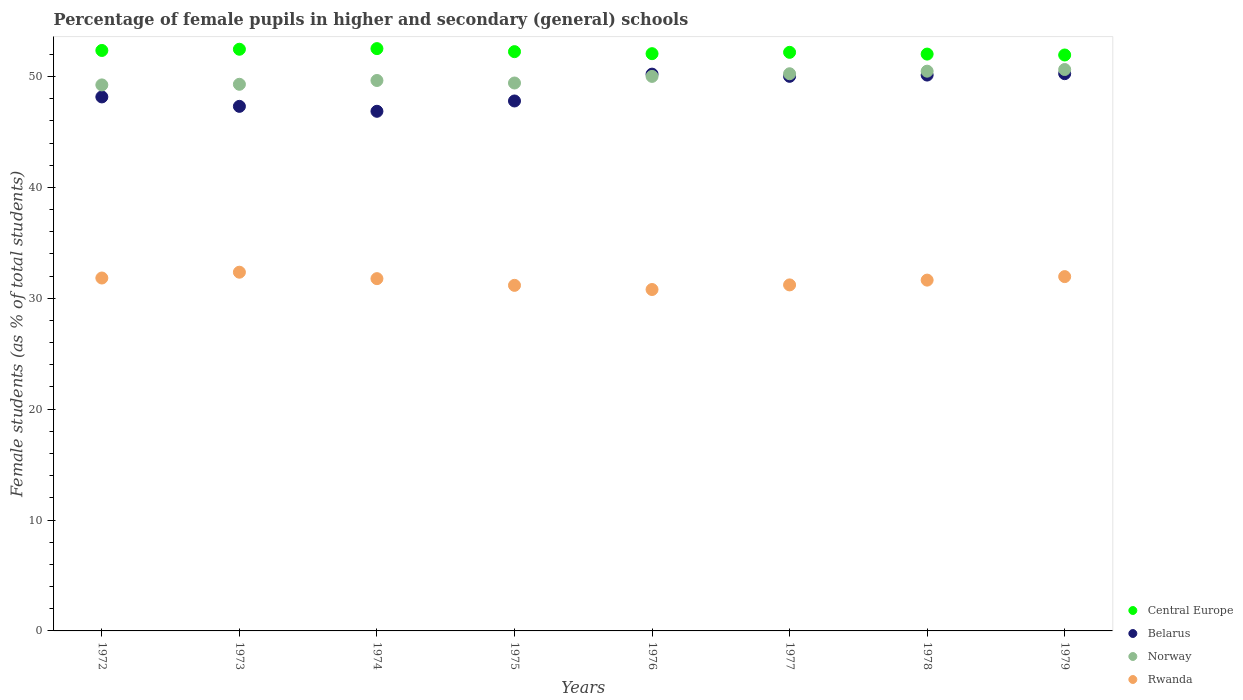What is the percentage of female pupils in higher and secondary schools in Central Europe in 1973?
Your answer should be compact. 52.46. Across all years, what is the maximum percentage of female pupils in higher and secondary schools in Central Europe?
Your answer should be very brief. 52.52. Across all years, what is the minimum percentage of female pupils in higher and secondary schools in Norway?
Provide a short and direct response. 49.24. In which year was the percentage of female pupils in higher and secondary schools in Belarus maximum?
Provide a succinct answer. 1979. In which year was the percentage of female pupils in higher and secondary schools in Rwanda minimum?
Your answer should be very brief. 1976. What is the total percentage of female pupils in higher and secondary schools in Central Europe in the graph?
Your answer should be very brief. 417.77. What is the difference between the percentage of female pupils in higher and secondary schools in Belarus in 1973 and that in 1978?
Ensure brevity in your answer.  -2.82. What is the difference between the percentage of female pupils in higher and secondary schools in Norway in 1977 and the percentage of female pupils in higher and secondary schools in Rwanda in 1974?
Give a very brief answer. 18.48. What is the average percentage of female pupils in higher and secondary schools in Belarus per year?
Give a very brief answer. 48.84. In the year 1974, what is the difference between the percentage of female pupils in higher and secondary schools in Central Europe and percentage of female pupils in higher and secondary schools in Norway?
Provide a succinct answer. 2.87. What is the ratio of the percentage of female pupils in higher and secondary schools in Norway in 1976 to that in 1979?
Give a very brief answer. 0.99. Is the percentage of female pupils in higher and secondary schools in Rwanda in 1972 less than that in 1977?
Your answer should be very brief. No. What is the difference between the highest and the second highest percentage of female pupils in higher and secondary schools in Norway?
Your answer should be compact. 0.15. What is the difference between the highest and the lowest percentage of female pupils in higher and secondary schools in Belarus?
Keep it short and to the point. 3.39. Is it the case that in every year, the sum of the percentage of female pupils in higher and secondary schools in Belarus and percentage of female pupils in higher and secondary schools in Rwanda  is greater than the sum of percentage of female pupils in higher and secondary schools in Central Europe and percentage of female pupils in higher and secondary schools in Norway?
Make the answer very short. No. Is it the case that in every year, the sum of the percentage of female pupils in higher and secondary schools in Norway and percentage of female pupils in higher and secondary schools in Belarus  is greater than the percentage of female pupils in higher and secondary schools in Rwanda?
Your response must be concise. Yes. How many dotlines are there?
Give a very brief answer. 4. How many years are there in the graph?
Your response must be concise. 8. What is the difference between two consecutive major ticks on the Y-axis?
Ensure brevity in your answer.  10. Are the values on the major ticks of Y-axis written in scientific E-notation?
Offer a very short reply. No. Does the graph contain grids?
Provide a succinct answer. No. Where does the legend appear in the graph?
Keep it short and to the point. Bottom right. How many legend labels are there?
Your answer should be very brief. 4. How are the legend labels stacked?
Ensure brevity in your answer.  Vertical. What is the title of the graph?
Your response must be concise. Percentage of female pupils in higher and secondary (general) schools. What is the label or title of the Y-axis?
Keep it short and to the point. Female students (as % of total students). What is the Female students (as % of total students) in Central Europe in 1972?
Make the answer very short. 52.35. What is the Female students (as % of total students) in Belarus in 1972?
Give a very brief answer. 48.16. What is the Female students (as % of total students) of Norway in 1972?
Your answer should be very brief. 49.24. What is the Female students (as % of total students) of Rwanda in 1972?
Provide a succinct answer. 31.83. What is the Female students (as % of total students) of Central Europe in 1973?
Ensure brevity in your answer.  52.46. What is the Female students (as % of total students) in Belarus in 1973?
Give a very brief answer. 47.31. What is the Female students (as % of total students) in Norway in 1973?
Offer a terse response. 49.3. What is the Female students (as % of total students) in Rwanda in 1973?
Keep it short and to the point. 32.35. What is the Female students (as % of total students) in Central Europe in 1974?
Provide a succinct answer. 52.52. What is the Female students (as % of total students) of Belarus in 1974?
Your response must be concise. 46.86. What is the Female students (as % of total students) of Norway in 1974?
Make the answer very short. 49.64. What is the Female students (as % of total students) in Rwanda in 1974?
Provide a short and direct response. 31.77. What is the Female students (as % of total students) of Central Europe in 1975?
Ensure brevity in your answer.  52.24. What is the Female students (as % of total students) in Belarus in 1975?
Provide a short and direct response. 47.79. What is the Female students (as % of total students) in Norway in 1975?
Give a very brief answer. 49.42. What is the Female students (as % of total students) in Rwanda in 1975?
Make the answer very short. 31.17. What is the Female students (as % of total students) of Central Europe in 1976?
Your response must be concise. 52.06. What is the Female students (as % of total students) in Belarus in 1976?
Offer a very short reply. 50.22. What is the Female students (as % of total students) in Norway in 1976?
Keep it short and to the point. 50.01. What is the Female students (as % of total students) of Rwanda in 1976?
Give a very brief answer. 30.79. What is the Female students (as % of total students) in Central Europe in 1977?
Your answer should be compact. 52.18. What is the Female students (as % of total students) in Belarus in 1977?
Your answer should be very brief. 50.02. What is the Female students (as % of total students) of Norway in 1977?
Provide a succinct answer. 50.25. What is the Female students (as % of total students) of Rwanda in 1977?
Offer a very short reply. 31.21. What is the Female students (as % of total students) of Central Europe in 1978?
Offer a very short reply. 52.02. What is the Female students (as % of total students) of Belarus in 1978?
Your answer should be compact. 50.13. What is the Female students (as % of total students) of Norway in 1978?
Provide a short and direct response. 50.48. What is the Female students (as % of total students) in Rwanda in 1978?
Keep it short and to the point. 31.64. What is the Female students (as % of total students) of Central Europe in 1979?
Provide a succinct answer. 51.94. What is the Female students (as % of total students) of Belarus in 1979?
Offer a very short reply. 50.26. What is the Female students (as % of total students) of Norway in 1979?
Keep it short and to the point. 50.63. What is the Female students (as % of total students) of Rwanda in 1979?
Ensure brevity in your answer.  31.95. Across all years, what is the maximum Female students (as % of total students) in Central Europe?
Your answer should be compact. 52.52. Across all years, what is the maximum Female students (as % of total students) in Belarus?
Your answer should be compact. 50.26. Across all years, what is the maximum Female students (as % of total students) in Norway?
Your answer should be very brief. 50.63. Across all years, what is the maximum Female students (as % of total students) of Rwanda?
Offer a terse response. 32.35. Across all years, what is the minimum Female students (as % of total students) in Central Europe?
Make the answer very short. 51.94. Across all years, what is the minimum Female students (as % of total students) in Belarus?
Provide a succinct answer. 46.86. Across all years, what is the minimum Female students (as % of total students) of Norway?
Your response must be concise. 49.24. Across all years, what is the minimum Female students (as % of total students) of Rwanda?
Provide a short and direct response. 30.79. What is the total Female students (as % of total students) of Central Europe in the graph?
Make the answer very short. 417.77. What is the total Female students (as % of total students) in Belarus in the graph?
Ensure brevity in your answer.  390.75. What is the total Female students (as % of total students) in Norway in the graph?
Your response must be concise. 398.97. What is the total Female students (as % of total students) of Rwanda in the graph?
Provide a short and direct response. 252.7. What is the difference between the Female students (as % of total students) in Central Europe in 1972 and that in 1973?
Give a very brief answer. -0.11. What is the difference between the Female students (as % of total students) in Belarus in 1972 and that in 1973?
Keep it short and to the point. 0.85. What is the difference between the Female students (as % of total students) of Norway in 1972 and that in 1973?
Your answer should be very brief. -0.06. What is the difference between the Female students (as % of total students) of Rwanda in 1972 and that in 1973?
Make the answer very short. -0.52. What is the difference between the Female students (as % of total students) of Central Europe in 1972 and that in 1974?
Your response must be concise. -0.17. What is the difference between the Female students (as % of total students) of Belarus in 1972 and that in 1974?
Offer a terse response. 1.3. What is the difference between the Female students (as % of total students) of Norway in 1972 and that in 1974?
Your answer should be very brief. -0.4. What is the difference between the Female students (as % of total students) of Rwanda in 1972 and that in 1974?
Make the answer very short. 0.06. What is the difference between the Female students (as % of total students) of Central Europe in 1972 and that in 1975?
Your answer should be very brief. 0.11. What is the difference between the Female students (as % of total students) in Belarus in 1972 and that in 1975?
Offer a terse response. 0.37. What is the difference between the Female students (as % of total students) in Norway in 1972 and that in 1975?
Make the answer very short. -0.17. What is the difference between the Female students (as % of total students) of Rwanda in 1972 and that in 1975?
Make the answer very short. 0.66. What is the difference between the Female students (as % of total students) of Central Europe in 1972 and that in 1976?
Keep it short and to the point. 0.29. What is the difference between the Female students (as % of total students) in Belarus in 1972 and that in 1976?
Offer a very short reply. -2.06. What is the difference between the Female students (as % of total students) of Norway in 1972 and that in 1976?
Your response must be concise. -0.77. What is the difference between the Female students (as % of total students) of Rwanda in 1972 and that in 1976?
Make the answer very short. 1.04. What is the difference between the Female students (as % of total students) in Central Europe in 1972 and that in 1977?
Make the answer very short. 0.17. What is the difference between the Female students (as % of total students) of Belarus in 1972 and that in 1977?
Offer a terse response. -1.86. What is the difference between the Female students (as % of total students) in Norway in 1972 and that in 1977?
Keep it short and to the point. -1.01. What is the difference between the Female students (as % of total students) of Rwanda in 1972 and that in 1977?
Provide a succinct answer. 0.62. What is the difference between the Female students (as % of total students) in Central Europe in 1972 and that in 1978?
Your response must be concise. 0.33. What is the difference between the Female students (as % of total students) in Belarus in 1972 and that in 1978?
Offer a terse response. -1.97. What is the difference between the Female students (as % of total students) of Norway in 1972 and that in 1978?
Provide a short and direct response. -1.24. What is the difference between the Female students (as % of total students) in Rwanda in 1972 and that in 1978?
Provide a succinct answer. 0.19. What is the difference between the Female students (as % of total students) in Central Europe in 1972 and that in 1979?
Make the answer very short. 0.41. What is the difference between the Female students (as % of total students) in Belarus in 1972 and that in 1979?
Your answer should be very brief. -2.1. What is the difference between the Female students (as % of total students) of Norway in 1972 and that in 1979?
Provide a succinct answer. -1.39. What is the difference between the Female students (as % of total students) of Rwanda in 1972 and that in 1979?
Ensure brevity in your answer.  -0.13. What is the difference between the Female students (as % of total students) of Central Europe in 1973 and that in 1974?
Make the answer very short. -0.06. What is the difference between the Female students (as % of total students) of Belarus in 1973 and that in 1974?
Provide a succinct answer. 0.45. What is the difference between the Female students (as % of total students) of Norway in 1973 and that in 1974?
Your response must be concise. -0.34. What is the difference between the Female students (as % of total students) in Rwanda in 1973 and that in 1974?
Give a very brief answer. 0.58. What is the difference between the Female students (as % of total students) in Central Europe in 1973 and that in 1975?
Keep it short and to the point. 0.22. What is the difference between the Female students (as % of total students) of Belarus in 1973 and that in 1975?
Keep it short and to the point. -0.49. What is the difference between the Female students (as % of total students) of Norway in 1973 and that in 1975?
Your answer should be very brief. -0.12. What is the difference between the Female students (as % of total students) of Rwanda in 1973 and that in 1975?
Ensure brevity in your answer.  1.19. What is the difference between the Female students (as % of total students) of Central Europe in 1973 and that in 1976?
Your answer should be very brief. 0.4. What is the difference between the Female students (as % of total students) of Belarus in 1973 and that in 1976?
Ensure brevity in your answer.  -2.91. What is the difference between the Female students (as % of total students) in Norway in 1973 and that in 1976?
Provide a short and direct response. -0.71. What is the difference between the Female students (as % of total students) in Rwanda in 1973 and that in 1976?
Offer a terse response. 1.56. What is the difference between the Female students (as % of total students) of Central Europe in 1973 and that in 1977?
Offer a terse response. 0.28. What is the difference between the Female students (as % of total students) in Belarus in 1973 and that in 1977?
Your answer should be very brief. -2.71. What is the difference between the Female students (as % of total students) of Norway in 1973 and that in 1977?
Your answer should be very brief. -0.95. What is the difference between the Female students (as % of total students) in Rwanda in 1973 and that in 1977?
Your response must be concise. 1.15. What is the difference between the Female students (as % of total students) in Central Europe in 1973 and that in 1978?
Your response must be concise. 0.44. What is the difference between the Female students (as % of total students) in Belarus in 1973 and that in 1978?
Offer a very short reply. -2.82. What is the difference between the Female students (as % of total students) in Norway in 1973 and that in 1978?
Keep it short and to the point. -1.18. What is the difference between the Female students (as % of total students) in Rwanda in 1973 and that in 1978?
Offer a very short reply. 0.71. What is the difference between the Female students (as % of total students) in Central Europe in 1973 and that in 1979?
Provide a short and direct response. 0.52. What is the difference between the Female students (as % of total students) of Belarus in 1973 and that in 1979?
Keep it short and to the point. -2.95. What is the difference between the Female students (as % of total students) in Norway in 1973 and that in 1979?
Provide a short and direct response. -1.33. What is the difference between the Female students (as % of total students) of Rwanda in 1973 and that in 1979?
Provide a succinct answer. 0.4. What is the difference between the Female students (as % of total students) of Central Europe in 1974 and that in 1975?
Provide a short and direct response. 0.27. What is the difference between the Female students (as % of total students) in Belarus in 1974 and that in 1975?
Offer a very short reply. -0.93. What is the difference between the Female students (as % of total students) of Norway in 1974 and that in 1975?
Give a very brief answer. 0.23. What is the difference between the Female students (as % of total students) in Rwanda in 1974 and that in 1975?
Provide a short and direct response. 0.61. What is the difference between the Female students (as % of total students) in Central Europe in 1974 and that in 1976?
Make the answer very short. 0.46. What is the difference between the Female students (as % of total students) of Belarus in 1974 and that in 1976?
Offer a terse response. -3.35. What is the difference between the Female students (as % of total students) of Norway in 1974 and that in 1976?
Give a very brief answer. -0.37. What is the difference between the Female students (as % of total students) of Rwanda in 1974 and that in 1976?
Ensure brevity in your answer.  0.98. What is the difference between the Female students (as % of total students) in Central Europe in 1974 and that in 1977?
Your response must be concise. 0.33. What is the difference between the Female students (as % of total students) in Belarus in 1974 and that in 1977?
Offer a terse response. -3.15. What is the difference between the Female students (as % of total students) of Norway in 1974 and that in 1977?
Your answer should be compact. -0.61. What is the difference between the Female students (as % of total students) of Rwanda in 1974 and that in 1977?
Give a very brief answer. 0.56. What is the difference between the Female students (as % of total students) in Central Europe in 1974 and that in 1978?
Provide a succinct answer. 0.49. What is the difference between the Female students (as % of total students) in Belarus in 1974 and that in 1978?
Your response must be concise. -3.27. What is the difference between the Female students (as % of total students) of Norway in 1974 and that in 1978?
Your response must be concise. -0.84. What is the difference between the Female students (as % of total students) of Rwanda in 1974 and that in 1978?
Your answer should be compact. 0.13. What is the difference between the Female students (as % of total students) of Central Europe in 1974 and that in 1979?
Your response must be concise. 0.57. What is the difference between the Female students (as % of total students) of Belarus in 1974 and that in 1979?
Offer a very short reply. -3.39. What is the difference between the Female students (as % of total students) of Norway in 1974 and that in 1979?
Provide a succinct answer. -0.99. What is the difference between the Female students (as % of total students) of Rwanda in 1974 and that in 1979?
Offer a very short reply. -0.18. What is the difference between the Female students (as % of total students) in Central Europe in 1975 and that in 1976?
Your answer should be very brief. 0.18. What is the difference between the Female students (as % of total students) of Belarus in 1975 and that in 1976?
Your response must be concise. -2.42. What is the difference between the Female students (as % of total students) in Norway in 1975 and that in 1976?
Provide a short and direct response. -0.6. What is the difference between the Female students (as % of total students) of Rwanda in 1975 and that in 1976?
Offer a terse response. 0.38. What is the difference between the Female students (as % of total students) in Central Europe in 1975 and that in 1977?
Offer a terse response. 0.06. What is the difference between the Female students (as % of total students) in Belarus in 1975 and that in 1977?
Provide a succinct answer. -2.22. What is the difference between the Female students (as % of total students) in Norway in 1975 and that in 1977?
Your response must be concise. -0.83. What is the difference between the Female students (as % of total students) in Rwanda in 1975 and that in 1977?
Provide a short and direct response. -0.04. What is the difference between the Female students (as % of total students) in Central Europe in 1975 and that in 1978?
Give a very brief answer. 0.22. What is the difference between the Female students (as % of total students) in Belarus in 1975 and that in 1978?
Your response must be concise. -2.34. What is the difference between the Female students (as % of total students) of Norway in 1975 and that in 1978?
Offer a very short reply. -1.07. What is the difference between the Female students (as % of total students) of Rwanda in 1975 and that in 1978?
Keep it short and to the point. -0.47. What is the difference between the Female students (as % of total students) of Central Europe in 1975 and that in 1979?
Make the answer very short. 0.3. What is the difference between the Female students (as % of total students) in Belarus in 1975 and that in 1979?
Make the answer very short. -2.46. What is the difference between the Female students (as % of total students) in Norway in 1975 and that in 1979?
Offer a very short reply. -1.22. What is the difference between the Female students (as % of total students) of Rwanda in 1975 and that in 1979?
Provide a short and direct response. -0.79. What is the difference between the Female students (as % of total students) of Central Europe in 1976 and that in 1977?
Offer a very short reply. -0.12. What is the difference between the Female students (as % of total students) in Belarus in 1976 and that in 1977?
Make the answer very short. 0.2. What is the difference between the Female students (as % of total students) in Norway in 1976 and that in 1977?
Your answer should be very brief. -0.24. What is the difference between the Female students (as % of total students) in Rwanda in 1976 and that in 1977?
Offer a terse response. -0.42. What is the difference between the Female students (as % of total students) of Central Europe in 1976 and that in 1978?
Offer a terse response. 0.04. What is the difference between the Female students (as % of total students) of Belarus in 1976 and that in 1978?
Give a very brief answer. 0.08. What is the difference between the Female students (as % of total students) of Norway in 1976 and that in 1978?
Your response must be concise. -0.47. What is the difference between the Female students (as % of total students) of Rwanda in 1976 and that in 1978?
Make the answer very short. -0.85. What is the difference between the Female students (as % of total students) of Central Europe in 1976 and that in 1979?
Your answer should be very brief. 0.12. What is the difference between the Female students (as % of total students) in Belarus in 1976 and that in 1979?
Make the answer very short. -0.04. What is the difference between the Female students (as % of total students) of Norway in 1976 and that in 1979?
Ensure brevity in your answer.  -0.62. What is the difference between the Female students (as % of total students) of Rwanda in 1976 and that in 1979?
Provide a short and direct response. -1.16. What is the difference between the Female students (as % of total students) of Central Europe in 1977 and that in 1978?
Your response must be concise. 0.16. What is the difference between the Female students (as % of total students) in Belarus in 1977 and that in 1978?
Provide a short and direct response. -0.12. What is the difference between the Female students (as % of total students) in Norway in 1977 and that in 1978?
Offer a very short reply. -0.23. What is the difference between the Female students (as % of total students) in Rwanda in 1977 and that in 1978?
Give a very brief answer. -0.43. What is the difference between the Female students (as % of total students) in Central Europe in 1977 and that in 1979?
Provide a succinct answer. 0.24. What is the difference between the Female students (as % of total students) in Belarus in 1977 and that in 1979?
Your answer should be very brief. -0.24. What is the difference between the Female students (as % of total students) of Norway in 1977 and that in 1979?
Give a very brief answer. -0.38. What is the difference between the Female students (as % of total students) in Rwanda in 1977 and that in 1979?
Your answer should be compact. -0.75. What is the difference between the Female students (as % of total students) in Central Europe in 1978 and that in 1979?
Provide a short and direct response. 0.08. What is the difference between the Female students (as % of total students) of Belarus in 1978 and that in 1979?
Provide a short and direct response. -0.12. What is the difference between the Female students (as % of total students) of Norway in 1978 and that in 1979?
Make the answer very short. -0.15. What is the difference between the Female students (as % of total students) of Rwanda in 1978 and that in 1979?
Offer a terse response. -0.32. What is the difference between the Female students (as % of total students) in Central Europe in 1972 and the Female students (as % of total students) in Belarus in 1973?
Your response must be concise. 5.04. What is the difference between the Female students (as % of total students) in Central Europe in 1972 and the Female students (as % of total students) in Norway in 1973?
Give a very brief answer. 3.05. What is the difference between the Female students (as % of total students) in Central Europe in 1972 and the Female students (as % of total students) in Rwanda in 1973?
Ensure brevity in your answer.  20. What is the difference between the Female students (as % of total students) of Belarus in 1972 and the Female students (as % of total students) of Norway in 1973?
Your answer should be compact. -1.14. What is the difference between the Female students (as % of total students) in Belarus in 1972 and the Female students (as % of total students) in Rwanda in 1973?
Your answer should be compact. 15.81. What is the difference between the Female students (as % of total students) of Norway in 1972 and the Female students (as % of total students) of Rwanda in 1973?
Your answer should be very brief. 16.89. What is the difference between the Female students (as % of total students) of Central Europe in 1972 and the Female students (as % of total students) of Belarus in 1974?
Keep it short and to the point. 5.49. What is the difference between the Female students (as % of total students) of Central Europe in 1972 and the Female students (as % of total students) of Norway in 1974?
Give a very brief answer. 2.71. What is the difference between the Female students (as % of total students) of Central Europe in 1972 and the Female students (as % of total students) of Rwanda in 1974?
Keep it short and to the point. 20.58. What is the difference between the Female students (as % of total students) of Belarus in 1972 and the Female students (as % of total students) of Norway in 1974?
Keep it short and to the point. -1.48. What is the difference between the Female students (as % of total students) of Belarus in 1972 and the Female students (as % of total students) of Rwanda in 1974?
Make the answer very short. 16.39. What is the difference between the Female students (as % of total students) of Norway in 1972 and the Female students (as % of total students) of Rwanda in 1974?
Your response must be concise. 17.47. What is the difference between the Female students (as % of total students) in Central Europe in 1972 and the Female students (as % of total students) in Belarus in 1975?
Offer a very short reply. 4.56. What is the difference between the Female students (as % of total students) in Central Europe in 1972 and the Female students (as % of total students) in Norway in 1975?
Make the answer very short. 2.93. What is the difference between the Female students (as % of total students) of Central Europe in 1972 and the Female students (as % of total students) of Rwanda in 1975?
Your response must be concise. 21.18. What is the difference between the Female students (as % of total students) of Belarus in 1972 and the Female students (as % of total students) of Norway in 1975?
Offer a very short reply. -1.26. What is the difference between the Female students (as % of total students) of Belarus in 1972 and the Female students (as % of total students) of Rwanda in 1975?
Provide a succinct answer. 16.99. What is the difference between the Female students (as % of total students) in Norway in 1972 and the Female students (as % of total students) in Rwanda in 1975?
Offer a terse response. 18.08. What is the difference between the Female students (as % of total students) in Central Europe in 1972 and the Female students (as % of total students) in Belarus in 1976?
Your answer should be compact. 2.13. What is the difference between the Female students (as % of total students) in Central Europe in 1972 and the Female students (as % of total students) in Norway in 1976?
Keep it short and to the point. 2.34. What is the difference between the Female students (as % of total students) in Central Europe in 1972 and the Female students (as % of total students) in Rwanda in 1976?
Your response must be concise. 21.56. What is the difference between the Female students (as % of total students) in Belarus in 1972 and the Female students (as % of total students) in Norway in 1976?
Make the answer very short. -1.85. What is the difference between the Female students (as % of total students) of Belarus in 1972 and the Female students (as % of total students) of Rwanda in 1976?
Offer a terse response. 17.37. What is the difference between the Female students (as % of total students) in Norway in 1972 and the Female students (as % of total students) in Rwanda in 1976?
Ensure brevity in your answer.  18.45. What is the difference between the Female students (as % of total students) in Central Europe in 1972 and the Female students (as % of total students) in Belarus in 1977?
Your answer should be very brief. 2.33. What is the difference between the Female students (as % of total students) in Central Europe in 1972 and the Female students (as % of total students) in Norway in 1977?
Provide a short and direct response. 2.1. What is the difference between the Female students (as % of total students) in Central Europe in 1972 and the Female students (as % of total students) in Rwanda in 1977?
Provide a short and direct response. 21.14. What is the difference between the Female students (as % of total students) in Belarus in 1972 and the Female students (as % of total students) in Norway in 1977?
Provide a short and direct response. -2.09. What is the difference between the Female students (as % of total students) of Belarus in 1972 and the Female students (as % of total students) of Rwanda in 1977?
Provide a succinct answer. 16.95. What is the difference between the Female students (as % of total students) of Norway in 1972 and the Female students (as % of total students) of Rwanda in 1977?
Give a very brief answer. 18.04. What is the difference between the Female students (as % of total students) in Central Europe in 1972 and the Female students (as % of total students) in Belarus in 1978?
Provide a succinct answer. 2.22. What is the difference between the Female students (as % of total students) in Central Europe in 1972 and the Female students (as % of total students) in Norway in 1978?
Make the answer very short. 1.87. What is the difference between the Female students (as % of total students) in Central Europe in 1972 and the Female students (as % of total students) in Rwanda in 1978?
Offer a very short reply. 20.71. What is the difference between the Female students (as % of total students) of Belarus in 1972 and the Female students (as % of total students) of Norway in 1978?
Provide a succinct answer. -2.32. What is the difference between the Female students (as % of total students) of Belarus in 1972 and the Female students (as % of total students) of Rwanda in 1978?
Provide a short and direct response. 16.52. What is the difference between the Female students (as % of total students) of Norway in 1972 and the Female students (as % of total students) of Rwanda in 1978?
Offer a terse response. 17.61. What is the difference between the Female students (as % of total students) in Central Europe in 1972 and the Female students (as % of total students) in Belarus in 1979?
Provide a succinct answer. 2.09. What is the difference between the Female students (as % of total students) in Central Europe in 1972 and the Female students (as % of total students) in Norway in 1979?
Keep it short and to the point. 1.72. What is the difference between the Female students (as % of total students) in Central Europe in 1972 and the Female students (as % of total students) in Rwanda in 1979?
Keep it short and to the point. 20.4. What is the difference between the Female students (as % of total students) of Belarus in 1972 and the Female students (as % of total students) of Norway in 1979?
Your answer should be very brief. -2.47. What is the difference between the Female students (as % of total students) in Belarus in 1972 and the Female students (as % of total students) in Rwanda in 1979?
Offer a very short reply. 16.21. What is the difference between the Female students (as % of total students) of Norway in 1972 and the Female students (as % of total students) of Rwanda in 1979?
Your answer should be compact. 17.29. What is the difference between the Female students (as % of total students) of Central Europe in 1973 and the Female students (as % of total students) of Belarus in 1974?
Ensure brevity in your answer.  5.6. What is the difference between the Female students (as % of total students) in Central Europe in 1973 and the Female students (as % of total students) in Norway in 1974?
Offer a terse response. 2.82. What is the difference between the Female students (as % of total students) in Central Europe in 1973 and the Female students (as % of total students) in Rwanda in 1974?
Your answer should be very brief. 20.69. What is the difference between the Female students (as % of total students) of Belarus in 1973 and the Female students (as % of total students) of Norway in 1974?
Offer a very short reply. -2.33. What is the difference between the Female students (as % of total students) of Belarus in 1973 and the Female students (as % of total students) of Rwanda in 1974?
Your answer should be very brief. 15.54. What is the difference between the Female students (as % of total students) of Norway in 1973 and the Female students (as % of total students) of Rwanda in 1974?
Offer a terse response. 17.53. What is the difference between the Female students (as % of total students) in Central Europe in 1973 and the Female students (as % of total students) in Belarus in 1975?
Make the answer very short. 4.66. What is the difference between the Female students (as % of total students) of Central Europe in 1973 and the Female students (as % of total students) of Norway in 1975?
Provide a succinct answer. 3.04. What is the difference between the Female students (as % of total students) in Central Europe in 1973 and the Female students (as % of total students) in Rwanda in 1975?
Provide a short and direct response. 21.29. What is the difference between the Female students (as % of total students) in Belarus in 1973 and the Female students (as % of total students) in Norway in 1975?
Your answer should be very brief. -2.11. What is the difference between the Female students (as % of total students) of Belarus in 1973 and the Female students (as % of total students) of Rwanda in 1975?
Keep it short and to the point. 16.14. What is the difference between the Female students (as % of total students) of Norway in 1973 and the Female students (as % of total students) of Rwanda in 1975?
Ensure brevity in your answer.  18.13. What is the difference between the Female students (as % of total students) of Central Europe in 1973 and the Female students (as % of total students) of Belarus in 1976?
Offer a very short reply. 2.24. What is the difference between the Female students (as % of total students) of Central Europe in 1973 and the Female students (as % of total students) of Norway in 1976?
Offer a very short reply. 2.45. What is the difference between the Female students (as % of total students) of Central Europe in 1973 and the Female students (as % of total students) of Rwanda in 1976?
Provide a succinct answer. 21.67. What is the difference between the Female students (as % of total students) of Belarus in 1973 and the Female students (as % of total students) of Norway in 1976?
Ensure brevity in your answer.  -2.7. What is the difference between the Female students (as % of total students) of Belarus in 1973 and the Female students (as % of total students) of Rwanda in 1976?
Ensure brevity in your answer.  16.52. What is the difference between the Female students (as % of total students) in Norway in 1973 and the Female students (as % of total students) in Rwanda in 1976?
Keep it short and to the point. 18.51. What is the difference between the Female students (as % of total students) of Central Europe in 1973 and the Female students (as % of total students) of Belarus in 1977?
Offer a terse response. 2.44. What is the difference between the Female students (as % of total students) of Central Europe in 1973 and the Female students (as % of total students) of Norway in 1977?
Ensure brevity in your answer.  2.21. What is the difference between the Female students (as % of total students) in Central Europe in 1973 and the Female students (as % of total students) in Rwanda in 1977?
Your response must be concise. 21.25. What is the difference between the Female students (as % of total students) of Belarus in 1973 and the Female students (as % of total students) of Norway in 1977?
Your answer should be very brief. -2.94. What is the difference between the Female students (as % of total students) in Belarus in 1973 and the Female students (as % of total students) in Rwanda in 1977?
Offer a terse response. 16.1. What is the difference between the Female students (as % of total students) in Norway in 1973 and the Female students (as % of total students) in Rwanda in 1977?
Keep it short and to the point. 18.09. What is the difference between the Female students (as % of total students) of Central Europe in 1973 and the Female students (as % of total students) of Belarus in 1978?
Ensure brevity in your answer.  2.33. What is the difference between the Female students (as % of total students) in Central Europe in 1973 and the Female students (as % of total students) in Norway in 1978?
Make the answer very short. 1.98. What is the difference between the Female students (as % of total students) in Central Europe in 1973 and the Female students (as % of total students) in Rwanda in 1978?
Your response must be concise. 20.82. What is the difference between the Female students (as % of total students) of Belarus in 1973 and the Female students (as % of total students) of Norway in 1978?
Your answer should be compact. -3.17. What is the difference between the Female students (as % of total students) in Belarus in 1973 and the Female students (as % of total students) in Rwanda in 1978?
Give a very brief answer. 15.67. What is the difference between the Female students (as % of total students) in Norway in 1973 and the Female students (as % of total students) in Rwanda in 1978?
Offer a very short reply. 17.66. What is the difference between the Female students (as % of total students) of Central Europe in 1973 and the Female students (as % of total students) of Belarus in 1979?
Offer a very short reply. 2.2. What is the difference between the Female students (as % of total students) in Central Europe in 1973 and the Female students (as % of total students) in Norway in 1979?
Give a very brief answer. 1.83. What is the difference between the Female students (as % of total students) of Central Europe in 1973 and the Female students (as % of total students) of Rwanda in 1979?
Keep it short and to the point. 20.5. What is the difference between the Female students (as % of total students) of Belarus in 1973 and the Female students (as % of total students) of Norway in 1979?
Ensure brevity in your answer.  -3.32. What is the difference between the Female students (as % of total students) of Belarus in 1973 and the Female students (as % of total students) of Rwanda in 1979?
Offer a very short reply. 15.35. What is the difference between the Female students (as % of total students) in Norway in 1973 and the Female students (as % of total students) in Rwanda in 1979?
Give a very brief answer. 17.34. What is the difference between the Female students (as % of total students) of Central Europe in 1974 and the Female students (as % of total students) of Belarus in 1975?
Give a very brief answer. 4.72. What is the difference between the Female students (as % of total students) in Central Europe in 1974 and the Female students (as % of total students) in Norway in 1975?
Your response must be concise. 3.1. What is the difference between the Female students (as % of total students) of Central Europe in 1974 and the Female students (as % of total students) of Rwanda in 1975?
Offer a terse response. 21.35. What is the difference between the Female students (as % of total students) of Belarus in 1974 and the Female students (as % of total students) of Norway in 1975?
Provide a short and direct response. -2.55. What is the difference between the Female students (as % of total students) of Belarus in 1974 and the Female students (as % of total students) of Rwanda in 1975?
Provide a succinct answer. 15.7. What is the difference between the Female students (as % of total students) in Norway in 1974 and the Female students (as % of total students) in Rwanda in 1975?
Ensure brevity in your answer.  18.48. What is the difference between the Female students (as % of total students) in Central Europe in 1974 and the Female students (as % of total students) in Belarus in 1976?
Provide a short and direct response. 2.3. What is the difference between the Female students (as % of total students) of Central Europe in 1974 and the Female students (as % of total students) of Norway in 1976?
Your response must be concise. 2.51. What is the difference between the Female students (as % of total students) of Central Europe in 1974 and the Female students (as % of total students) of Rwanda in 1976?
Your answer should be compact. 21.73. What is the difference between the Female students (as % of total students) of Belarus in 1974 and the Female students (as % of total students) of Norway in 1976?
Your answer should be compact. -3.15. What is the difference between the Female students (as % of total students) of Belarus in 1974 and the Female students (as % of total students) of Rwanda in 1976?
Provide a succinct answer. 16.07. What is the difference between the Female students (as % of total students) in Norway in 1974 and the Female students (as % of total students) in Rwanda in 1976?
Your answer should be compact. 18.85. What is the difference between the Female students (as % of total students) in Central Europe in 1974 and the Female students (as % of total students) in Belarus in 1977?
Keep it short and to the point. 2.5. What is the difference between the Female students (as % of total students) of Central Europe in 1974 and the Female students (as % of total students) of Norway in 1977?
Make the answer very short. 2.27. What is the difference between the Female students (as % of total students) of Central Europe in 1974 and the Female students (as % of total students) of Rwanda in 1977?
Offer a very short reply. 21.31. What is the difference between the Female students (as % of total students) of Belarus in 1974 and the Female students (as % of total students) of Norway in 1977?
Ensure brevity in your answer.  -3.39. What is the difference between the Female students (as % of total students) in Belarus in 1974 and the Female students (as % of total students) in Rwanda in 1977?
Offer a very short reply. 15.66. What is the difference between the Female students (as % of total students) in Norway in 1974 and the Female students (as % of total students) in Rwanda in 1977?
Your response must be concise. 18.44. What is the difference between the Female students (as % of total students) in Central Europe in 1974 and the Female students (as % of total students) in Belarus in 1978?
Ensure brevity in your answer.  2.38. What is the difference between the Female students (as % of total students) of Central Europe in 1974 and the Female students (as % of total students) of Norway in 1978?
Your answer should be compact. 2.04. What is the difference between the Female students (as % of total students) in Central Europe in 1974 and the Female students (as % of total students) in Rwanda in 1978?
Offer a terse response. 20.88. What is the difference between the Female students (as % of total students) in Belarus in 1974 and the Female students (as % of total students) in Norway in 1978?
Make the answer very short. -3.62. What is the difference between the Female students (as % of total students) of Belarus in 1974 and the Female students (as % of total students) of Rwanda in 1978?
Give a very brief answer. 15.23. What is the difference between the Female students (as % of total students) of Norway in 1974 and the Female students (as % of total students) of Rwanda in 1978?
Offer a terse response. 18. What is the difference between the Female students (as % of total students) of Central Europe in 1974 and the Female students (as % of total students) of Belarus in 1979?
Provide a succinct answer. 2.26. What is the difference between the Female students (as % of total students) in Central Europe in 1974 and the Female students (as % of total students) in Norway in 1979?
Make the answer very short. 1.89. What is the difference between the Female students (as % of total students) in Central Europe in 1974 and the Female students (as % of total students) in Rwanda in 1979?
Keep it short and to the point. 20.56. What is the difference between the Female students (as % of total students) of Belarus in 1974 and the Female students (as % of total students) of Norway in 1979?
Ensure brevity in your answer.  -3.77. What is the difference between the Female students (as % of total students) of Belarus in 1974 and the Female students (as % of total students) of Rwanda in 1979?
Your answer should be compact. 14.91. What is the difference between the Female students (as % of total students) of Norway in 1974 and the Female students (as % of total students) of Rwanda in 1979?
Provide a succinct answer. 17.69. What is the difference between the Female students (as % of total students) in Central Europe in 1975 and the Female students (as % of total students) in Belarus in 1976?
Offer a very short reply. 2.03. What is the difference between the Female students (as % of total students) of Central Europe in 1975 and the Female students (as % of total students) of Norway in 1976?
Give a very brief answer. 2.23. What is the difference between the Female students (as % of total students) in Central Europe in 1975 and the Female students (as % of total students) in Rwanda in 1976?
Offer a very short reply. 21.45. What is the difference between the Female students (as % of total students) of Belarus in 1975 and the Female students (as % of total students) of Norway in 1976?
Your answer should be very brief. -2.22. What is the difference between the Female students (as % of total students) in Belarus in 1975 and the Female students (as % of total students) in Rwanda in 1976?
Give a very brief answer. 17. What is the difference between the Female students (as % of total students) of Norway in 1975 and the Female students (as % of total students) of Rwanda in 1976?
Your answer should be compact. 18.62. What is the difference between the Female students (as % of total students) in Central Europe in 1975 and the Female students (as % of total students) in Belarus in 1977?
Make the answer very short. 2.23. What is the difference between the Female students (as % of total students) in Central Europe in 1975 and the Female students (as % of total students) in Norway in 1977?
Your response must be concise. 1.99. What is the difference between the Female students (as % of total students) in Central Europe in 1975 and the Female students (as % of total students) in Rwanda in 1977?
Offer a very short reply. 21.04. What is the difference between the Female students (as % of total students) in Belarus in 1975 and the Female students (as % of total students) in Norway in 1977?
Make the answer very short. -2.45. What is the difference between the Female students (as % of total students) in Belarus in 1975 and the Female students (as % of total students) in Rwanda in 1977?
Ensure brevity in your answer.  16.59. What is the difference between the Female students (as % of total students) in Norway in 1975 and the Female students (as % of total students) in Rwanda in 1977?
Your answer should be very brief. 18.21. What is the difference between the Female students (as % of total students) of Central Europe in 1975 and the Female students (as % of total students) of Belarus in 1978?
Keep it short and to the point. 2.11. What is the difference between the Female students (as % of total students) in Central Europe in 1975 and the Female students (as % of total students) in Norway in 1978?
Offer a terse response. 1.76. What is the difference between the Female students (as % of total students) of Central Europe in 1975 and the Female students (as % of total students) of Rwanda in 1978?
Provide a short and direct response. 20.61. What is the difference between the Female students (as % of total students) of Belarus in 1975 and the Female students (as % of total students) of Norway in 1978?
Provide a short and direct response. -2.69. What is the difference between the Female students (as % of total students) in Belarus in 1975 and the Female students (as % of total students) in Rwanda in 1978?
Provide a succinct answer. 16.16. What is the difference between the Female students (as % of total students) of Norway in 1975 and the Female students (as % of total students) of Rwanda in 1978?
Provide a succinct answer. 17.78. What is the difference between the Female students (as % of total students) of Central Europe in 1975 and the Female students (as % of total students) of Belarus in 1979?
Offer a terse response. 1.99. What is the difference between the Female students (as % of total students) in Central Europe in 1975 and the Female students (as % of total students) in Norway in 1979?
Offer a very short reply. 1.61. What is the difference between the Female students (as % of total students) in Central Europe in 1975 and the Female students (as % of total students) in Rwanda in 1979?
Your response must be concise. 20.29. What is the difference between the Female students (as % of total students) in Belarus in 1975 and the Female students (as % of total students) in Norway in 1979?
Keep it short and to the point. -2.84. What is the difference between the Female students (as % of total students) in Belarus in 1975 and the Female students (as % of total students) in Rwanda in 1979?
Your answer should be very brief. 15.84. What is the difference between the Female students (as % of total students) of Norway in 1975 and the Female students (as % of total students) of Rwanda in 1979?
Provide a succinct answer. 17.46. What is the difference between the Female students (as % of total students) of Central Europe in 1976 and the Female students (as % of total students) of Belarus in 1977?
Your answer should be compact. 2.04. What is the difference between the Female students (as % of total students) in Central Europe in 1976 and the Female students (as % of total students) in Norway in 1977?
Your answer should be compact. 1.81. What is the difference between the Female students (as % of total students) in Central Europe in 1976 and the Female students (as % of total students) in Rwanda in 1977?
Offer a terse response. 20.85. What is the difference between the Female students (as % of total students) in Belarus in 1976 and the Female students (as % of total students) in Norway in 1977?
Give a very brief answer. -0.03. What is the difference between the Female students (as % of total students) in Belarus in 1976 and the Female students (as % of total students) in Rwanda in 1977?
Your response must be concise. 19.01. What is the difference between the Female students (as % of total students) in Norway in 1976 and the Female students (as % of total students) in Rwanda in 1977?
Your answer should be very brief. 18.8. What is the difference between the Female students (as % of total students) in Central Europe in 1976 and the Female students (as % of total students) in Belarus in 1978?
Offer a very short reply. 1.93. What is the difference between the Female students (as % of total students) in Central Europe in 1976 and the Female students (as % of total students) in Norway in 1978?
Offer a terse response. 1.58. What is the difference between the Female students (as % of total students) in Central Europe in 1976 and the Female students (as % of total students) in Rwanda in 1978?
Make the answer very short. 20.42. What is the difference between the Female students (as % of total students) of Belarus in 1976 and the Female students (as % of total students) of Norway in 1978?
Your answer should be compact. -0.27. What is the difference between the Female students (as % of total students) in Belarus in 1976 and the Female students (as % of total students) in Rwanda in 1978?
Offer a terse response. 18.58. What is the difference between the Female students (as % of total students) of Norway in 1976 and the Female students (as % of total students) of Rwanda in 1978?
Offer a terse response. 18.37. What is the difference between the Female students (as % of total students) in Central Europe in 1976 and the Female students (as % of total students) in Belarus in 1979?
Provide a short and direct response. 1.8. What is the difference between the Female students (as % of total students) of Central Europe in 1976 and the Female students (as % of total students) of Norway in 1979?
Provide a short and direct response. 1.43. What is the difference between the Female students (as % of total students) of Central Europe in 1976 and the Female students (as % of total students) of Rwanda in 1979?
Offer a very short reply. 20.11. What is the difference between the Female students (as % of total students) in Belarus in 1976 and the Female students (as % of total students) in Norway in 1979?
Ensure brevity in your answer.  -0.42. What is the difference between the Female students (as % of total students) in Belarus in 1976 and the Female students (as % of total students) in Rwanda in 1979?
Offer a terse response. 18.26. What is the difference between the Female students (as % of total students) of Norway in 1976 and the Female students (as % of total students) of Rwanda in 1979?
Your response must be concise. 18.06. What is the difference between the Female students (as % of total students) of Central Europe in 1977 and the Female students (as % of total students) of Belarus in 1978?
Provide a short and direct response. 2.05. What is the difference between the Female students (as % of total students) in Central Europe in 1977 and the Female students (as % of total students) in Norway in 1978?
Your answer should be very brief. 1.7. What is the difference between the Female students (as % of total students) of Central Europe in 1977 and the Female students (as % of total students) of Rwanda in 1978?
Offer a very short reply. 20.54. What is the difference between the Female students (as % of total students) in Belarus in 1977 and the Female students (as % of total students) in Norway in 1978?
Ensure brevity in your answer.  -0.46. What is the difference between the Female students (as % of total students) in Belarus in 1977 and the Female students (as % of total students) in Rwanda in 1978?
Provide a short and direct response. 18.38. What is the difference between the Female students (as % of total students) in Norway in 1977 and the Female students (as % of total students) in Rwanda in 1978?
Ensure brevity in your answer.  18.61. What is the difference between the Female students (as % of total students) in Central Europe in 1977 and the Female students (as % of total students) in Belarus in 1979?
Provide a succinct answer. 1.92. What is the difference between the Female students (as % of total students) of Central Europe in 1977 and the Female students (as % of total students) of Norway in 1979?
Provide a succinct answer. 1.55. What is the difference between the Female students (as % of total students) in Central Europe in 1977 and the Female students (as % of total students) in Rwanda in 1979?
Keep it short and to the point. 20.23. What is the difference between the Female students (as % of total students) of Belarus in 1977 and the Female students (as % of total students) of Norway in 1979?
Give a very brief answer. -0.61. What is the difference between the Female students (as % of total students) of Belarus in 1977 and the Female students (as % of total students) of Rwanda in 1979?
Keep it short and to the point. 18.06. What is the difference between the Female students (as % of total students) in Norway in 1977 and the Female students (as % of total students) in Rwanda in 1979?
Offer a very short reply. 18.29. What is the difference between the Female students (as % of total students) of Central Europe in 1978 and the Female students (as % of total students) of Belarus in 1979?
Keep it short and to the point. 1.77. What is the difference between the Female students (as % of total students) of Central Europe in 1978 and the Female students (as % of total students) of Norway in 1979?
Your answer should be compact. 1.39. What is the difference between the Female students (as % of total students) in Central Europe in 1978 and the Female students (as % of total students) in Rwanda in 1979?
Offer a very short reply. 20.07. What is the difference between the Female students (as % of total students) of Belarus in 1978 and the Female students (as % of total students) of Norway in 1979?
Give a very brief answer. -0.5. What is the difference between the Female students (as % of total students) of Belarus in 1978 and the Female students (as % of total students) of Rwanda in 1979?
Your response must be concise. 18.18. What is the difference between the Female students (as % of total students) in Norway in 1978 and the Female students (as % of total students) in Rwanda in 1979?
Give a very brief answer. 18.53. What is the average Female students (as % of total students) in Central Europe per year?
Give a very brief answer. 52.22. What is the average Female students (as % of total students) in Belarus per year?
Provide a succinct answer. 48.84. What is the average Female students (as % of total students) of Norway per year?
Offer a terse response. 49.87. What is the average Female students (as % of total students) of Rwanda per year?
Your answer should be compact. 31.59. In the year 1972, what is the difference between the Female students (as % of total students) in Central Europe and Female students (as % of total students) in Belarus?
Offer a terse response. 4.19. In the year 1972, what is the difference between the Female students (as % of total students) in Central Europe and Female students (as % of total students) in Norway?
Give a very brief answer. 3.11. In the year 1972, what is the difference between the Female students (as % of total students) of Central Europe and Female students (as % of total students) of Rwanda?
Make the answer very short. 20.52. In the year 1972, what is the difference between the Female students (as % of total students) of Belarus and Female students (as % of total students) of Norway?
Your response must be concise. -1.08. In the year 1972, what is the difference between the Female students (as % of total students) in Belarus and Female students (as % of total students) in Rwanda?
Make the answer very short. 16.33. In the year 1972, what is the difference between the Female students (as % of total students) in Norway and Female students (as % of total students) in Rwanda?
Your answer should be very brief. 17.42. In the year 1973, what is the difference between the Female students (as % of total students) in Central Europe and Female students (as % of total students) in Belarus?
Your answer should be compact. 5.15. In the year 1973, what is the difference between the Female students (as % of total students) of Central Europe and Female students (as % of total students) of Norway?
Offer a terse response. 3.16. In the year 1973, what is the difference between the Female students (as % of total students) of Central Europe and Female students (as % of total students) of Rwanda?
Make the answer very short. 20.11. In the year 1973, what is the difference between the Female students (as % of total students) in Belarus and Female students (as % of total students) in Norway?
Your response must be concise. -1.99. In the year 1973, what is the difference between the Female students (as % of total students) of Belarus and Female students (as % of total students) of Rwanda?
Give a very brief answer. 14.96. In the year 1973, what is the difference between the Female students (as % of total students) of Norway and Female students (as % of total students) of Rwanda?
Provide a short and direct response. 16.95. In the year 1974, what is the difference between the Female students (as % of total students) of Central Europe and Female students (as % of total students) of Belarus?
Your answer should be compact. 5.65. In the year 1974, what is the difference between the Female students (as % of total students) of Central Europe and Female students (as % of total students) of Norway?
Offer a terse response. 2.87. In the year 1974, what is the difference between the Female students (as % of total students) of Central Europe and Female students (as % of total students) of Rwanda?
Offer a terse response. 20.74. In the year 1974, what is the difference between the Female students (as % of total students) of Belarus and Female students (as % of total students) of Norway?
Your answer should be very brief. -2.78. In the year 1974, what is the difference between the Female students (as % of total students) of Belarus and Female students (as % of total students) of Rwanda?
Keep it short and to the point. 15.09. In the year 1974, what is the difference between the Female students (as % of total students) of Norway and Female students (as % of total students) of Rwanda?
Offer a very short reply. 17.87. In the year 1975, what is the difference between the Female students (as % of total students) of Central Europe and Female students (as % of total students) of Belarus?
Offer a terse response. 4.45. In the year 1975, what is the difference between the Female students (as % of total students) in Central Europe and Female students (as % of total students) in Norway?
Make the answer very short. 2.83. In the year 1975, what is the difference between the Female students (as % of total students) of Central Europe and Female students (as % of total students) of Rwanda?
Provide a succinct answer. 21.08. In the year 1975, what is the difference between the Female students (as % of total students) of Belarus and Female students (as % of total students) of Norway?
Provide a succinct answer. -1.62. In the year 1975, what is the difference between the Female students (as % of total students) in Belarus and Female students (as % of total students) in Rwanda?
Give a very brief answer. 16.63. In the year 1975, what is the difference between the Female students (as % of total students) in Norway and Female students (as % of total students) in Rwanda?
Make the answer very short. 18.25. In the year 1976, what is the difference between the Female students (as % of total students) of Central Europe and Female students (as % of total students) of Belarus?
Ensure brevity in your answer.  1.84. In the year 1976, what is the difference between the Female students (as % of total students) in Central Europe and Female students (as % of total students) in Norway?
Provide a succinct answer. 2.05. In the year 1976, what is the difference between the Female students (as % of total students) of Central Europe and Female students (as % of total students) of Rwanda?
Give a very brief answer. 21.27. In the year 1976, what is the difference between the Female students (as % of total students) in Belarus and Female students (as % of total students) in Norway?
Ensure brevity in your answer.  0.2. In the year 1976, what is the difference between the Female students (as % of total students) of Belarus and Female students (as % of total students) of Rwanda?
Offer a terse response. 19.42. In the year 1976, what is the difference between the Female students (as % of total students) of Norway and Female students (as % of total students) of Rwanda?
Provide a short and direct response. 19.22. In the year 1977, what is the difference between the Female students (as % of total students) in Central Europe and Female students (as % of total students) in Belarus?
Offer a very short reply. 2.16. In the year 1977, what is the difference between the Female students (as % of total students) in Central Europe and Female students (as % of total students) in Norway?
Keep it short and to the point. 1.93. In the year 1977, what is the difference between the Female students (as % of total students) in Central Europe and Female students (as % of total students) in Rwanda?
Offer a terse response. 20.97. In the year 1977, what is the difference between the Female students (as % of total students) in Belarus and Female students (as % of total students) in Norway?
Give a very brief answer. -0.23. In the year 1977, what is the difference between the Female students (as % of total students) of Belarus and Female students (as % of total students) of Rwanda?
Your response must be concise. 18.81. In the year 1977, what is the difference between the Female students (as % of total students) of Norway and Female students (as % of total students) of Rwanda?
Your answer should be compact. 19.04. In the year 1978, what is the difference between the Female students (as % of total students) of Central Europe and Female students (as % of total students) of Belarus?
Your response must be concise. 1.89. In the year 1978, what is the difference between the Female students (as % of total students) in Central Europe and Female students (as % of total students) in Norway?
Keep it short and to the point. 1.54. In the year 1978, what is the difference between the Female students (as % of total students) in Central Europe and Female students (as % of total students) in Rwanda?
Keep it short and to the point. 20.39. In the year 1978, what is the difference between the Female students (as % of total students) of Belarus and Female students (as % of total students) of Norway?
Your response must be concise. -0.35. In the year 1978, what is the difference between the Female students (as % of total students) of Belarus and Female students (as % of total students) of Rwanda?
Give a very brief answer. 18.49. In the year 1978, what is the difference between the Female students (as % of total students) of Norway and Female students (as % of total students) of Rwanda?
Give a very brief answer. 18.84. In the year 1979, what is the difference between the Female students (as % of total students) in Central Europe and Female students (as % of total students) in Belarus?
Give a very brief answer. 1.69. In the year 1979, what is the difference between the Female students (as % of total students) of Central Europe and Female students (as % of total students) of Norway?
Your response must be concise. 1.31. In the year 1979, what is the difference between the Female students (as % of total students) of Central Europe and Female students (as % of total students) of Rwanda?
Your answer should be compact. 19.99. In the year 1979, what is the difference between the Female students (as % of total students) of Belarus and Female students (as % of total students) of Norway?
Provide a succinct answer. -0.37. In the year 1979, what is the difference between the Female students (as % of total students) in Belarus and Female students (as % of total students) in Rwanda?
Offer a terse response. 18.3. In the year 1979, what is the difference between the Female students (as % of total students) in Norway and Female students (as % of total students) in Rwanda?
Provide a succinct answer. 18.68. What is the ratio of the Female students (as % of total students) in Norway in 1972 to that in 1973?
Offer a very short reply. 1. What is the ratio of the Female students (as % of total students) in Rwanda in 1972 to that in 1973?
Keep it short and to the point. 0.98. What is the ratio of the Female students (as % of total students) of Belarus in 1972 to that in 1974?
Give a very brief answer. 1.03. What is the ratio of the Female students (as % of total students) of Norway in 1972 to that in 1974?
Make the answer very short. 0.99. What is the ratio of the Female students (as % of total students) of Central Europe in 1972 to that in 1975?
Provide a short and direct response. 1. What is the ratio of the Female students (as % of total students) in Belarus in 1972 to that in 1975?
Your answer should be very brief. 1.01. What is the ratio of the Female students (as % of total students) of Rwanda in 1972 to that in 1975?
Your answer should be very brief. 1.02. What is the ratio of the Female students (as % of total students) in Central Europe in 1972 to that in 1976?
Provide a short and direct response. 1.01. What is the ratio of the Female students (as % of total students) in Belarus in 1972 to that in 1976?
Offer a very short reply. 0.96. What is the ratio of the Female students (as % of total students) in Norway in 1972 to that in 1976?
Your answer should be compact. 0.98. What is the ratio of the Female students (as % of total students) in Rwanda in 1972 to that in 1976?
Give a very brief answer. 1.03. What is the ratio of the Female students (as % of total students) of Central Europe in 1972 to that in 1977?
Keep it short and to the point. 1. What is the ratio of the Female students (as % of total students) of Belarus in 1972 to that in 1977?
Provide a short and direct response. 0.96. What is the ratio of the Female students (as % of total students) of Norway in 1972 to that in 1977?
Keep it short and to the point. 0.98. What is the ratio of the Female students (as % of total students) in Rwanda in 1972 to that in 1977?
Your response must be concise. 1.02. What is the ratio of the Female students (as % of total students) of Central Europe in 1972 to that in 1978?
Offer a terse response. 1.01. What is the ratio of the Female students (as % of total students) in Belarus in 1972 to that in 1978?
Make the answer very short. 0.96. What is the ratio of the Female students (as % of total students) in Norway in 1972 to that in 1978?
Your answer should be compact. 0.98. What is the ratio of the Female students (as % of total students) in Central Europe in 1972 to that in 1979?
Provide a succinct answer. 1.01. What is the ratio of the Female students (as % of total students) in Norway in 1972 to that in 1979?
Make the answer very short. 0.97. What is the ratio of the Female students (as % of total students) in Rwanda in 1972 to that in 1979?
Offer a terse response. 1. What is the ratio of the Female students (as % of total students) in Belarus in 1973 to that in 1974?
Offer a very short reply. 1.01. What is the ratio of the Female students (as % of total students) in Norway in 1973 to that in 1974?
Offer a very short reply. 0.99. What is the ratio of the Female students (as % of total students) in Rwanda in 1973 to that in 1974?
Ensure brevity in your answer.  1.02. What is the ratio of the Female students (as % of total students) of Belarus in 1973 to that in 1975?
Your response must be concise. 0.99. What is the ratio of the Female students (as % of total students) in Norway in 1973 to that in 1975?
Your answer should be compact. 1. What is the ratio of the Female students (as % of total students) in Rwanda in 1973 to that in 1975?
Offer a terse response. 1.04. What is the ratio of the Female students (as % of total students) of Central Europe in 1973 to that in 1976?
Your answer should be compact. 1.01. What is the ratio of the Female students (as % of total students) of Belarus in 1973 to that in 1976?
Offer a terse response. 0.94. What is the ratio of the Female students (as % of total students) in Norway in 1973 to that in 1976?
Offer a terse response. 0.99. What is the ratio of the Female students (as % of total students) of Rwanda in 1973 to that in 1976?
Your answer should be very brief. 1.05. What is the ratio of the Female students (as % of total students) in Central Europe in 1973 to that in 1977?
Your answer should be very brief. 1.01. What is the ratio of the Female students (as % of total students) of Belarus in 1973 to that in 1977?
Make the answer very short. 0.95. What is the ratio of the Female students (as % of total students) in Norway in 1973 to that in 1977?
Give a very brief answer. 0.98. What is the ratio of the Female students (as % of total students) in Rwanda in 1973 to that in 1977?
Make the answer very short. 1.04. What is the ratio of the Female students (as % of total students) of Central Europe in 1973 to that in 1978?
Your response must be concise. 1.01. What is the ratio of the Female students (as % of total students) of Belarus in 1973 to that in 1978?
Provide a succinct answer. 0.94. What is the ratio of the Female students (as % of total students) of Norway in 1973 to that in 1978?
Give a very brief answer. 0.98. What is the ratio of the Female students (as % of total students) of Rwanda in 1973 to that in 1978?
Provide a short and direct response. 1.02. What is the ratio of the Female students (as % of total students) of Belarus in 1973 to that in 1979?
Make the answer very short. 0.94. What is the ratio of the Female students (as % of total students) in Norway in 1973 to that in 1979?
Ensure brevity in your answer.  0.97. What is the ratio of the Female students (as % of total students) of Rwanda in 1973 to that in 1979?
Ensure brevity in your answer.  1.01. What is the ratio of the Female students (as % of total students) in Belarus in 1974 to that in 1975?
Offer a very short reply. 0.98. What is the ratio of the Female students (as % of total students) in Rwanda in 1974 to that in 1975?
Your response must be concise. 1.02. What is the ratio of the Female students (as % of total students) of Central Europe in 1974 to that in 1976?
Keep it short and to the point. 1.01. What is the ratio of the Female students (as % of total students) of Belarus in 1974 to that in 1976?
Make the answer very short. 0.93. What is the ratio of the Female students (as % of total students) of Norway in 1974 to that in 1976?
Make the answer very short. 0.99. What is the ratio of the Female students (as % of total students) of Rwanda in 1974 to that in 1976?
Give a very brief answer. 1.03. What is the ratio of the Female students (as % of total students) of Central Europe in 1974 to that in 1977?
Make the answer very short. 1.01. What is the ratio of the Female students (as % of total students) of Belarus in 1974 to that in 1977?
Your answer should be compact. 0.94. What is the ratio of the Female students (as % of total students) of Norway in 1974 to that in 1977?
Provide a succinct answer. 0.99. What is the ratio of the Female students (as % of total students) in Rwanda in 1974 to that in 1977?
Ensure brevity in your answer.  1.02. What is the ratio of the Female students (as % of total students) in Central Europe in 1974 to that in 1978?
Your response must be concise. 1.01. What is the ratio of the Female students (as % of total students) in Belarus in 1974 to that in 1978?
Your response must be concise. 0.93. What is the ratio of the Female students (as % of total students) in Norway in 1974 to that in 1978?
Keep it short and to the point. 0.98. What is the ratio of the Female students (as % of total students) of Central Europe in 1974 to that in 1979?
Your answer should be very brief. 1.01. What is the ratio of the Female students (as % of total students) in Belarus in 1974 to that in 1979?
Give a very brief answer. 0.93. What is the ratio of the Female students (as % of total students) of Norway in 1974 to that in 1979?
Offer a very short reply. 0.98. What is the ratio of the Female students (as % of total students) in Central Europe in 1975 to that in 1976?
Your answer should be compact. 1. What is the ratio of the Female students (as % of total students) in Belarus in 1975 to that in 1976?
Make the answer very short. 0.95. What is the ratio of the Female students (as % of total students) in Norway in 1975 to that in 1976?
Your answer should be very brief. 0.99. What is the ratio of the Female students (as % of total students) of Rwanda in 1975 to that in 1976?
Give a very brief answer. 1.01. What is the ratio of the Female students (as % of total students) in Central Europe in 1975 to that in 1977?
Provide a short and direct response. 1. What is the ratio of the Female students (as % of total students) of Belarus in 1975 to that in 1977?
Your response must be concise. 0.96. What is the ratio of the Female students (as % of total students) of Norway in 1975 to that in 1977?
Your answer should be very brief. 0.98. What is the ratio of the Female students (as % of total students) in Rwanda in 1975 to that in 1977?
Offer a terse response. 1. What is the ratio of the Female students (as % of total students) in Central Europe in 1975 to that in 1978?
Your answer should be very brief. 1. What is the ratio of the Female students (as % of total students) of Belarus in 1975 to that in 1978?
Provide a short and direct response. 0.95. What is the ratio of the Female students (as % of total students) of Norway in 1975 to that in 1978?
Give a very brief answer. 0.98. What is the ratio of the Female students (as % of total students) in Rwanda in 1975 to that in 1978?
Your answer should be compact. 0.99. What is the ratio of the Female students (as % of total students) in Belarus in 1975 to that in 1979?
Offer a very short reply. 0.95. What is the ratio of the Female students (as % of total students) in Norway in 1975 to that in 1979?
Ensure brevity in your answer.  0.98. What is the ratio of the Female students (as % of total students) of Rwanda in 1975 to that in 1979?
Your response must be concise. 0.98. What is the ratio of the Female students (as % of total students) in Central Europe in 1976 to that in 1977?
Ensure brevity in your answer.  1. What is the ratio of the Female students (as % of total students) in Norway in 1976 to that in 1977?
Ensure brevity in your answer.  1. What is the ratio of the Female students (as % of total students) in Rwanda in 1976 to that in 1977?
Provide a short and direct response. 0.99. What is the ratio of the Female students (as % of total students) in Central Europe in 1976 to that in 1978?
Provide a succinct answer. 1. What is the ratio of the Female students (as % of total students) in Rwanda in 1976 to that in 1978?
Offer a very short reply. 0.97. What is the ratio of the Female students (as % of total students) in Rwanda in 1976 to that in 1979?
Give a very brief answer. 0.96. What is the ratio of the Female students (as % of total students) of Norway in 1977 to that in 1978?
Offer a very short reply. 1. What is the ratio of the Female students (as % of total students) of Rwanda in 1977 to that in 1978?
Offer a very short reply. 0.99. What is the ratio of the Female students (as % of total students) in Rwanda in 1977 to that in 1979?
Your response must be concise. 0.98. What is the ratio of the Female students (as % of total students) in Central Europe in 1978 to that in 1979?
Give a very brief answer. 1. What is the ratio of the Female students (as % of total students) of Belarus in 1978 to that in 1979?
Give a very brief answer. 1. What is the ratio of the Female students (as % of total students) in Norway in 1978 to that in 1979?
Provide a short and direct response. 1. What is the ratio of the Female students (as % of total students) in Rwanda in 1978 to that in 1979?
Give a very brief answer. 0.99. What is the difference between the highest and the second highest Female students (as % of total students) in Central Europe?
Your response must be concise. 0.06. What is the difference between the highest and the second highest Female students (as % of total students) in Belarus?
Offer a terse response. 0.04. What is the difference between the highest and the second highest Female students (as % of total students) in Norway?
Ensure brevity in your answer.  0.15. What is the difference between the highest and the second highest Female students (as % of total students) of Rwanda?
Ensure brevity in your answer.  0.4. What is the difference between the highest and the lowest Female students (as % of total students) of Central Europe?
Offer a terse response. 0.57. What is the difference between the highest and the lowest Female students (as % of total students) in Belarus?
Keep it short and to the point. 3.39. What is the difference between the highest and the lowest Female students (as % of total students) of Norway?
Your response must be concise. 1.39. What is the difference between the highest and the lowest Female students (as % of total students) of Rwanda?
Offer a terse response. 1.56. 